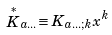<formula> <loc_0><loc_0><loc_500><loc_500>\stackrel { \ast } { K } _ { a \dots } \equiv K _ { a \dots ; k } x ^ { k }</formula> 